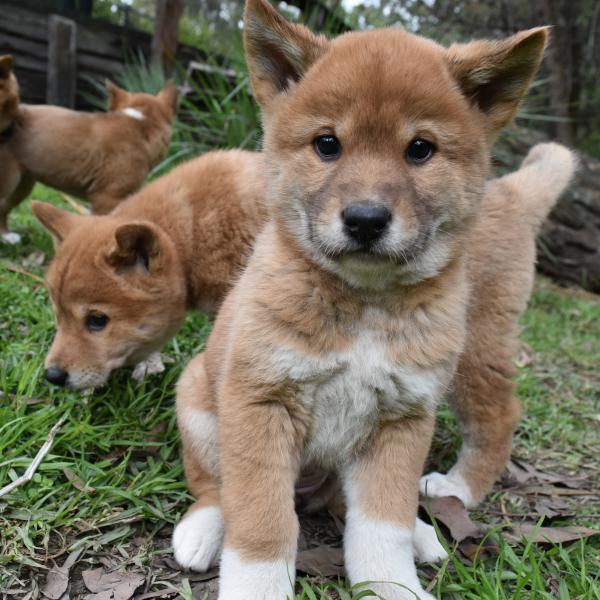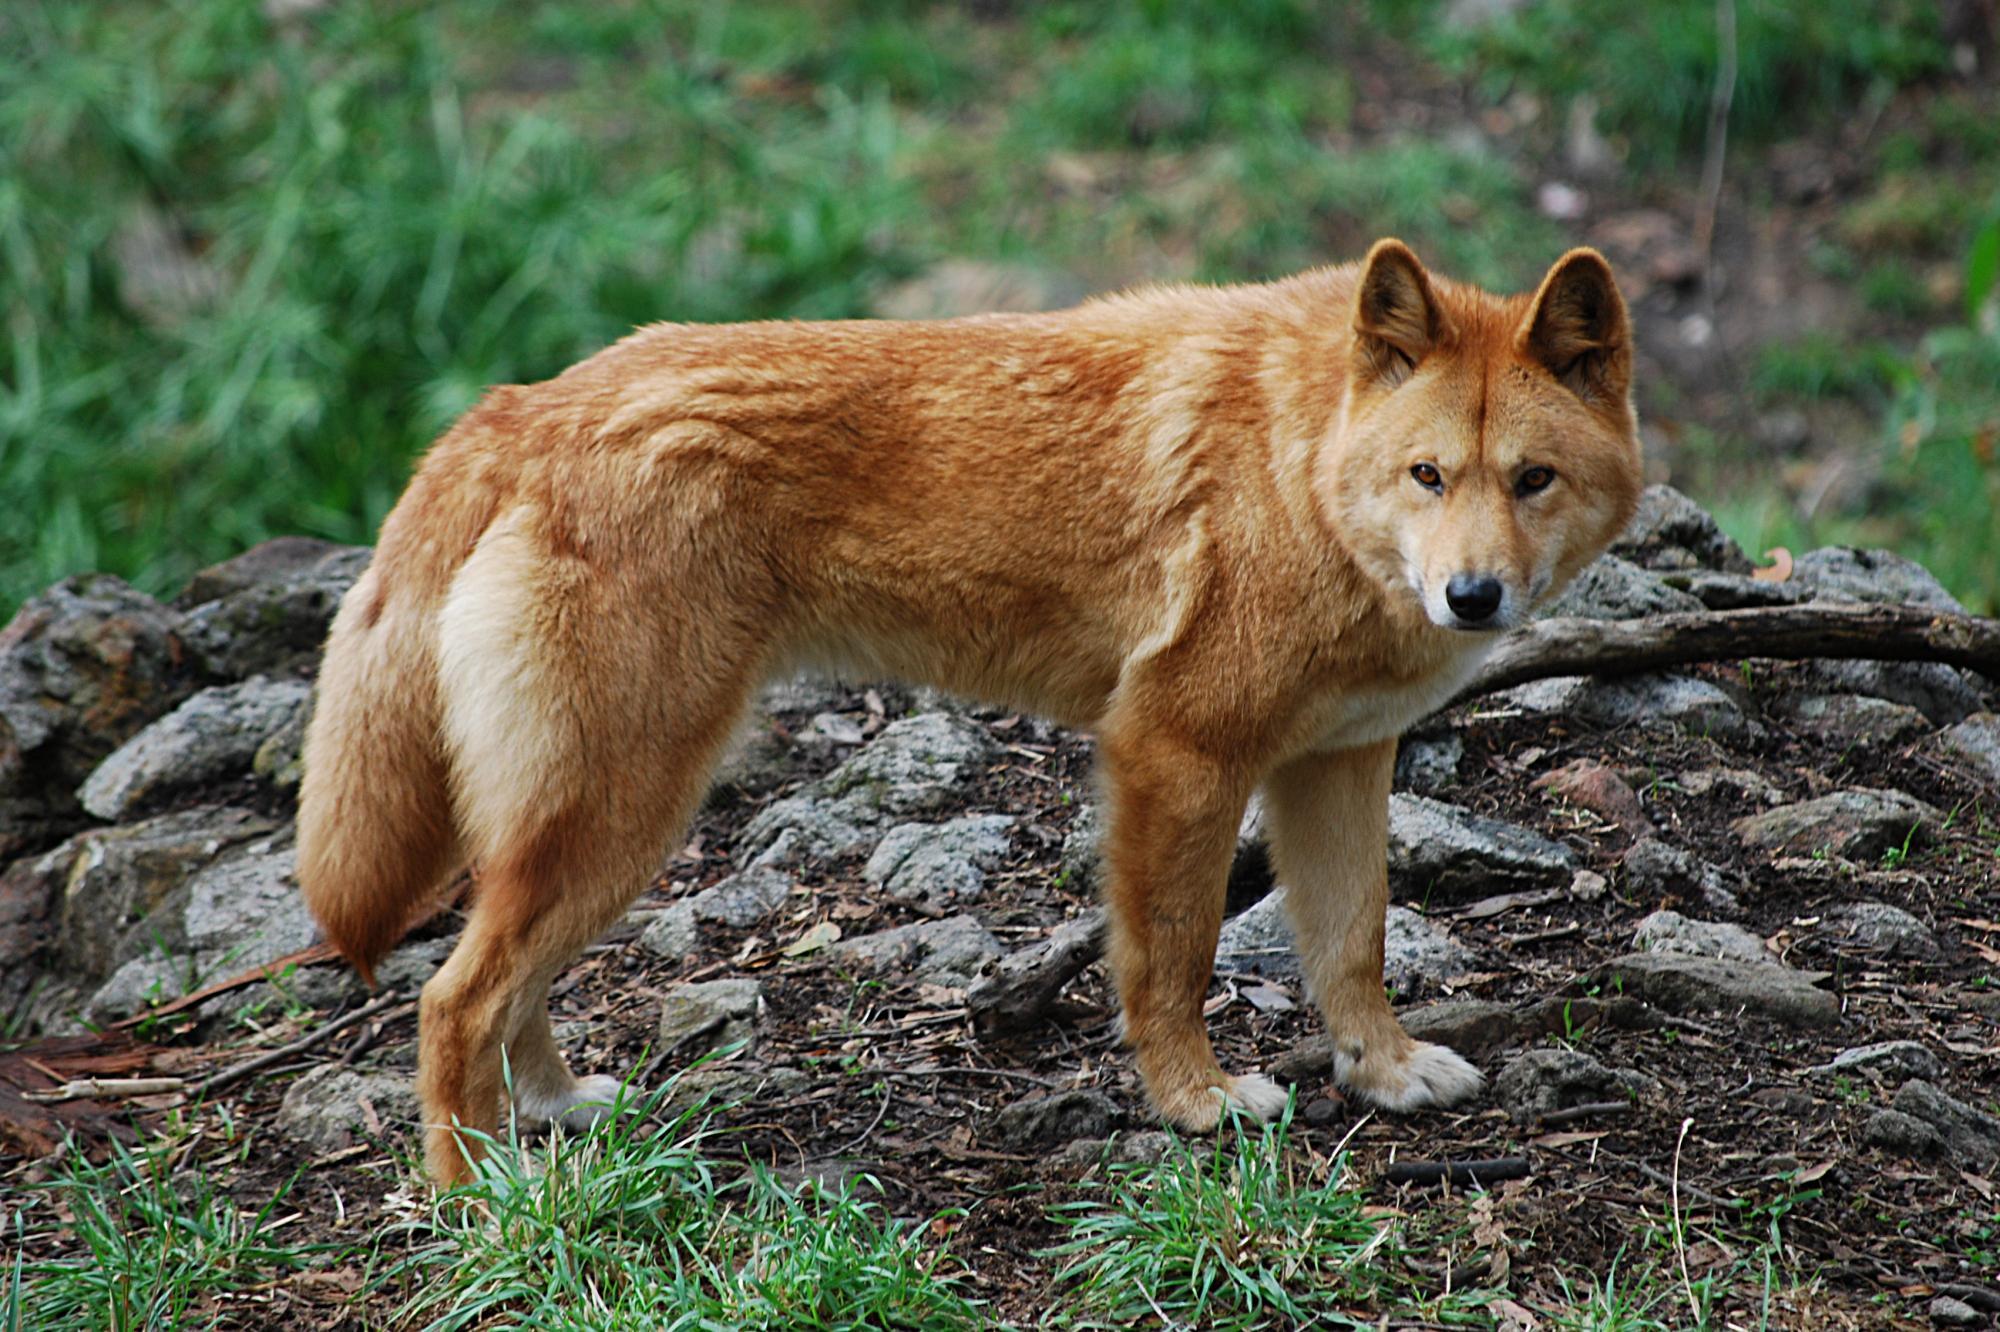The first image is the image on the left, the second image is the image on the right. Analyze the images presented: Is the assertion "Every photo shows exactly one dog and all dogs are photographed outside, but the dog on the right has a visible leash attached to its collar." valid? Answer yes or no. No. The first image is the image on the left, the second image is the image on the right. Evaluate the accuracy of this statement regarding the images: "Two dingo pups are overlapping in the left image, with the dingo pup in front facing the camera.". Is it true? Answer yes or no. Yes. 